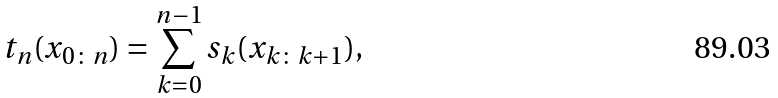Convert formula to latex. <formula><loc_0><loc_0><loc_500><loc_500>t _ { n } ( x _ { 0 \colon n } ) = \sum _ { k = 0 } ^ { n - 1 } s _ { k } ( x _ { k \colon k + 1 } ) ,</formula> 